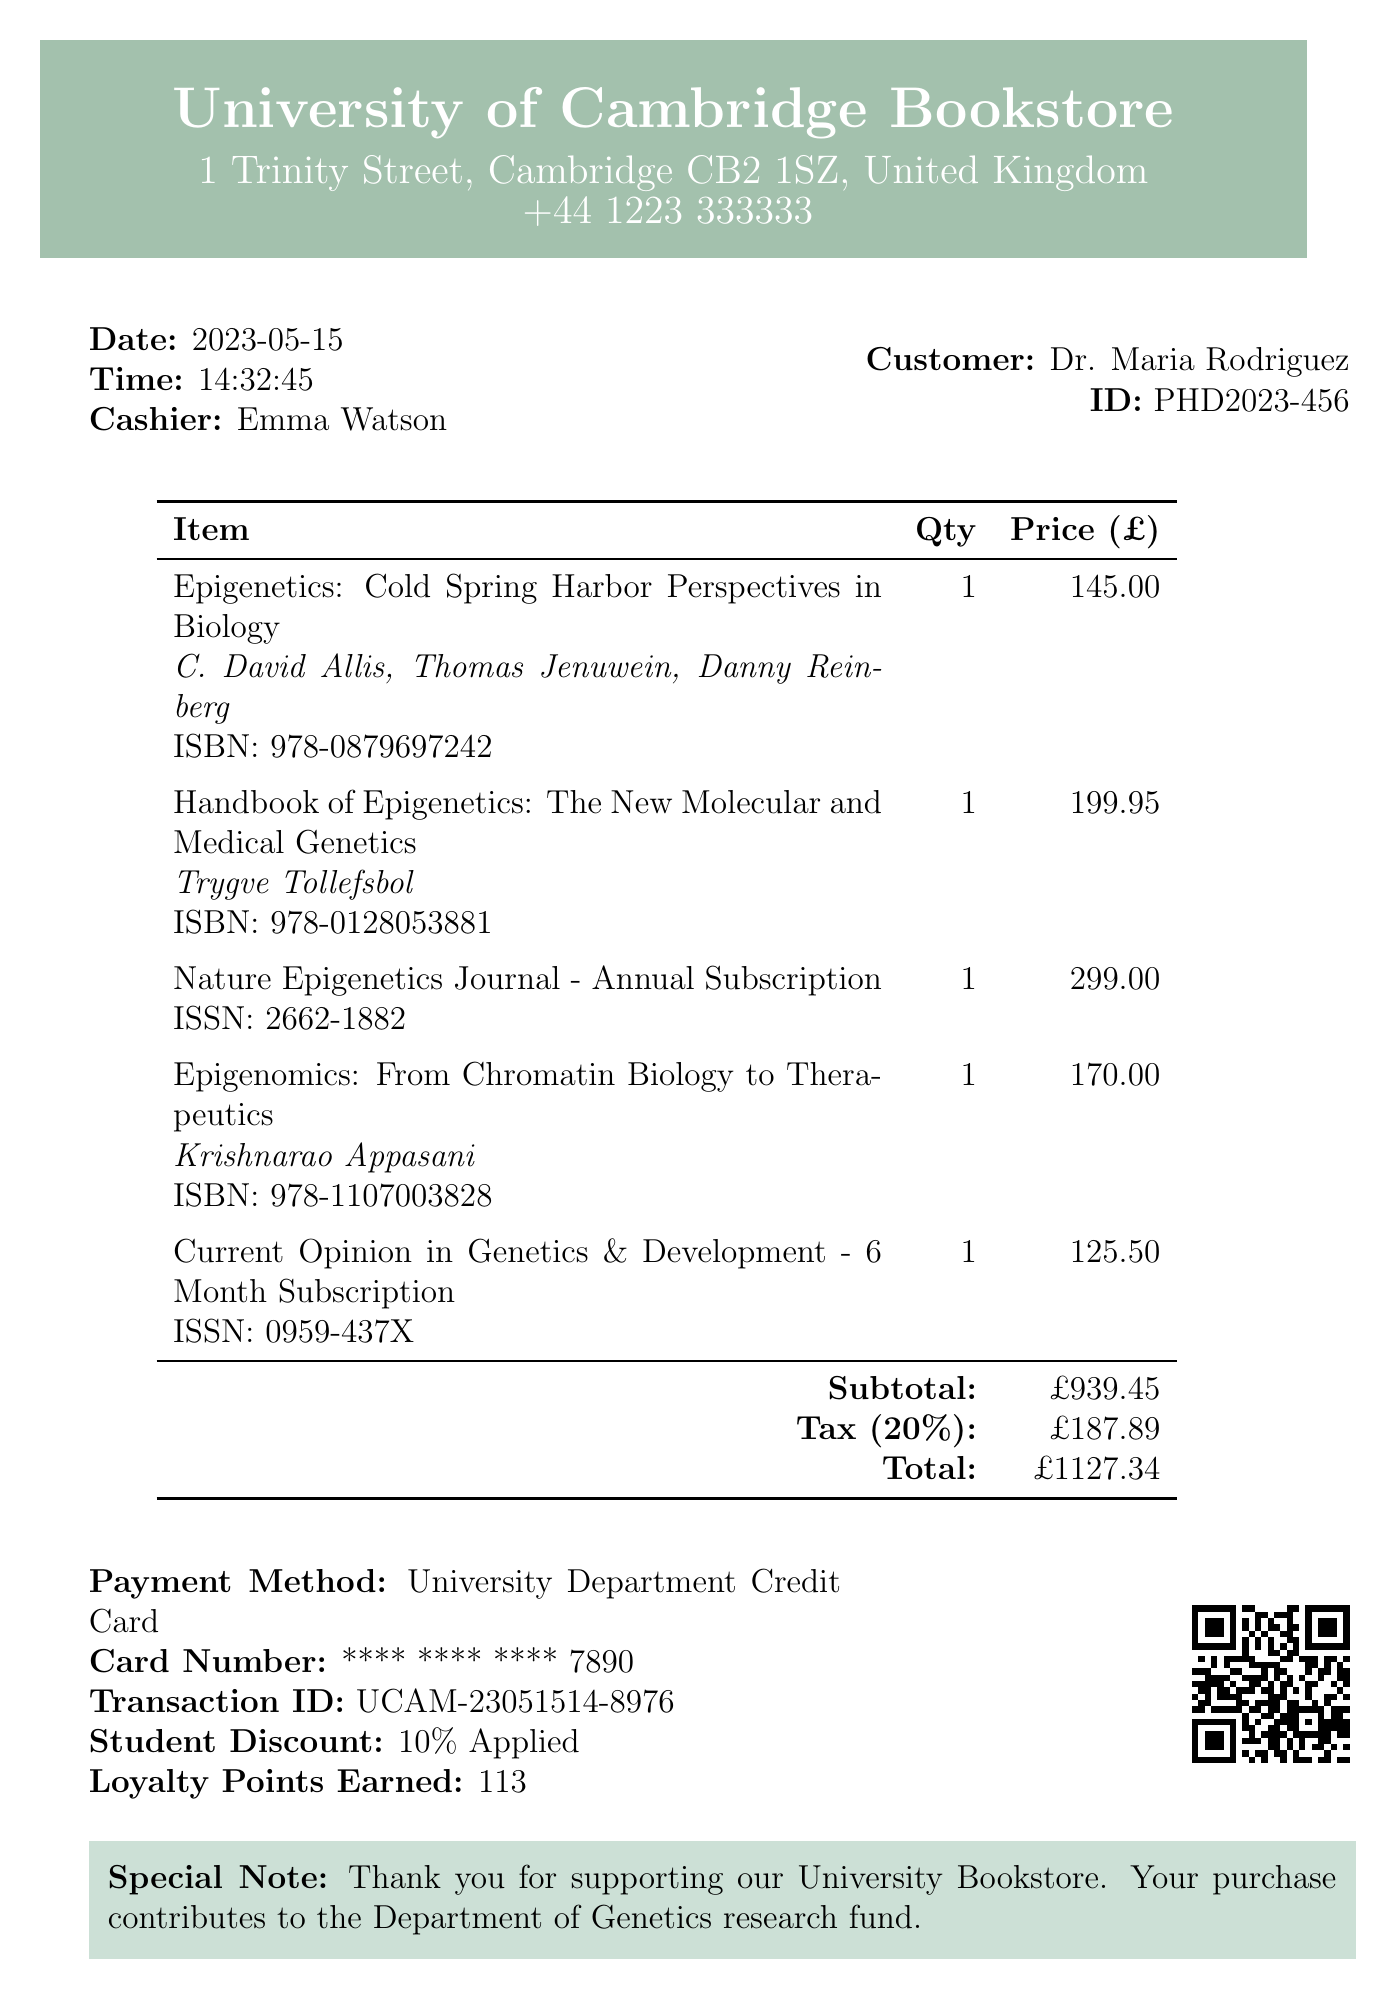What is the name of the bookstore? The bookstore name is presented at the top of the receipt.
Answer: University of Cambridge Bookstore What is the total amount spent? The total amount is the final calculation displayed at the end of the receipt.
Answer: £1127.34 Who was the cashier? The cashier's name is mentioned near the date and time of the purchase.
Answer: Emma Watson What is the date of purchase? The date of the transaction is clearly labeled on the receipt.
Answer: 2023-05-15 What is the ISBN of the book "Epigenetics: Cold Spring Harbor Perspectives in Biology"? The ISBN is provided under the title of the respective book.
Answer: 978-0879697242 How much was the student discount applied? The discount applied is indicated on the receipt in the payment information section.
Answer: 10% Applied What is the ISSN of the "Nature Epigenetics Journal"? The ISSN is given beside the journal title in the list of purchased items.
Answer: 2662-1882 What is the return policy for the items purchased? The return policy provides important information about returns at the end of the receipt.
Answer: Returns accepted within 14 days with original receipt How many loyalty points were earned from this purchase? The number of loyalty points earned is specified in the payment details section.
Answer: 113 